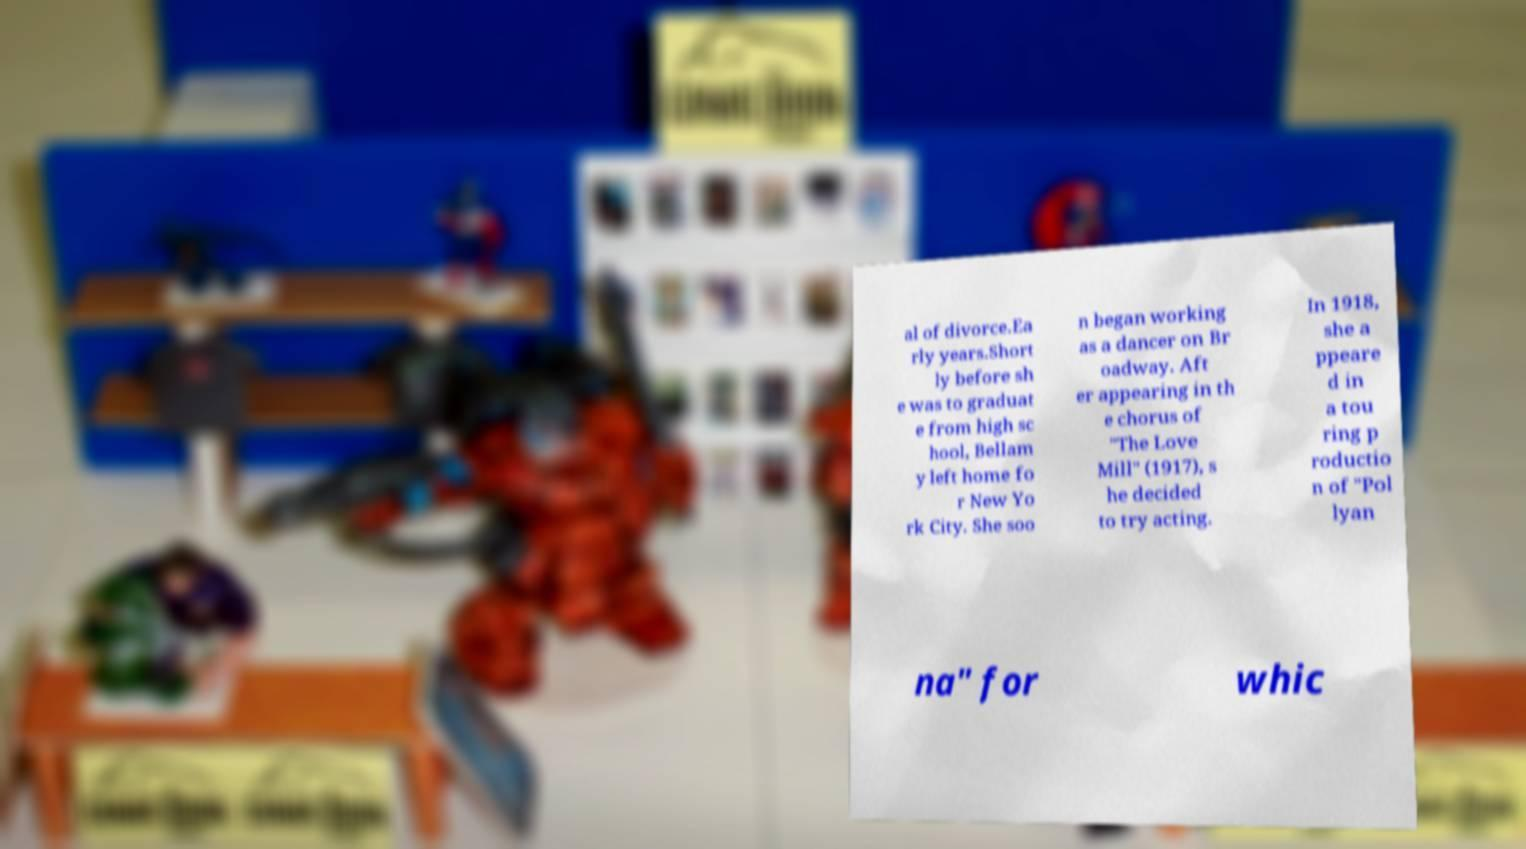Can you read and provide the text displayed in the image?This photo seems to have some interesting text. Can you extract and type it out for me? al of divorce.Ea rly years.Short ly before sh e was to graduat e from high sc hool, Bellam y left home fo r New Yo rk City. She soo n began working as a dancer on Br oadway. Aft er appearing in th e chorus of "The Love Mill" (1917), s he decided to try acting. In 1918, she a ppeare d in a tou ring p roductio n of "Pol lyan na" for whic 